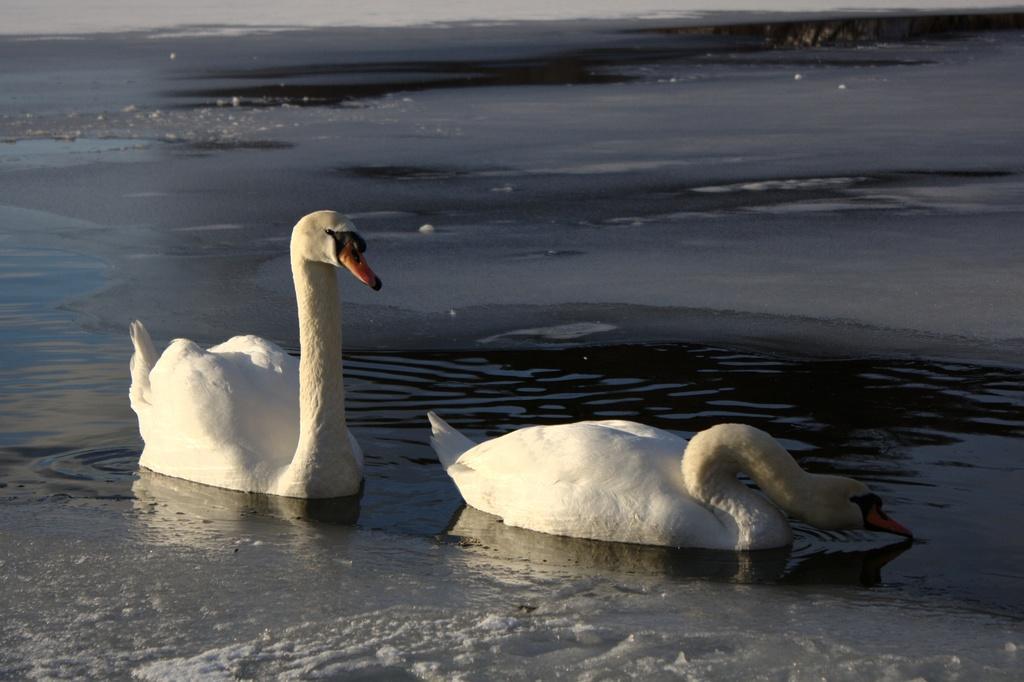Can you describe this image briefly? This image consists of water. In that there are swans. They are in white color. 